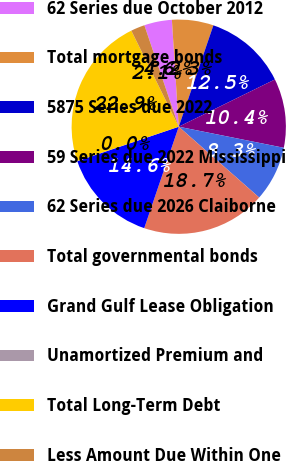<chart> <loc_0><loc_0><loc_500><loc_500><pie_chart><fcel>62 Series due October 2012<fcel>Total mortgage bonds<fcel>5875 Series due 2022<fcel>59 Series due 2022 Mississippi<fcel>62 Series due 2026 Claiborne<fcel>Total governmental bonds<fcel>Grand Gulf Lease Obligation<fcel>Unamortized Premium and<fcel>Total Long-Term Debt<fcel>Less Amount Due Within One<nl><fcel>4.18%<fcel>6.26%<fcel>12.49%<fcel>10.42%<fcel>8.34%<fcel>18.73%<fcel>14.57%<fcel>0.03%<fcel>22.88%<fcel>2.1%<nl></chart> 